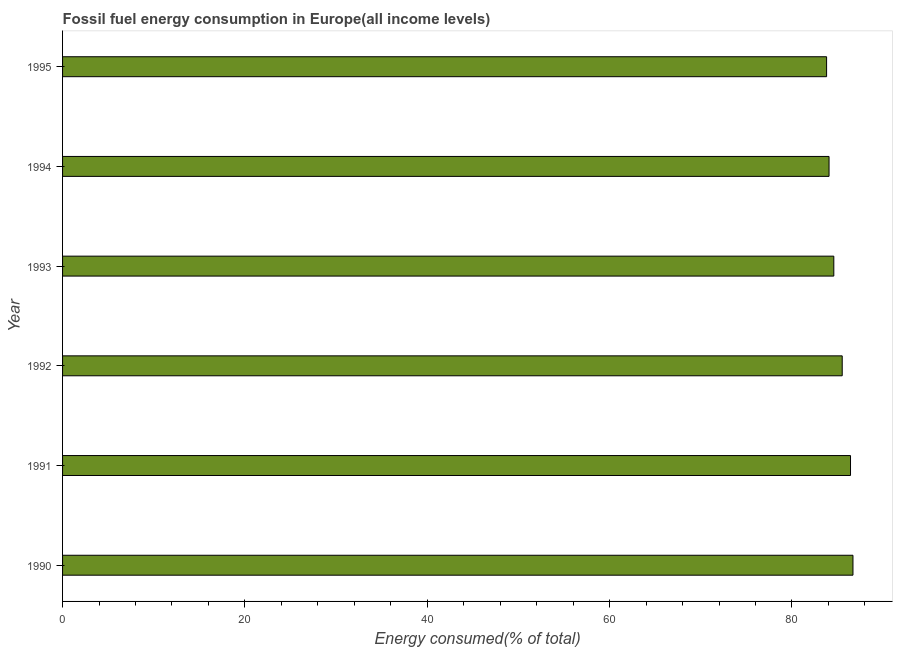Does the graph contain any zero values?
Offer a very short reply. No. What is the title of the graph?
Ensure brevity in your answer.  Fossil fuel energy consumption in Europe(all income levels). What is the label or title of the X-axis?
Offer a very short reply. Energy consumed(% of total). What is the fossil fuel energy consumption in 1995?
Give a very brief answer. 83.8. Across all years, what is the maximum fossil fuel energy consumption?
Your response must be concise. 86.69. Across all years, what is the minimum fossil fuel energy consumption?
Ensure brevity in your answer.  83.8. In which year was the fossil fuel energy consumption minimum?
Keep it short and to the point. 1995. What is the sum of the fossil fuel energy consumption?
Your answer should be very brief. 511.1. What is the difference between the fossil fuel energy consumption in 1990 and 1995?
Ensure brevity in your answer.  2.89. What is the average fossil fuel energy consumption per year?
Ensure brevity in your answer.  85.18. What is the median fossil fuel energy consumption?
Your answer should be compact. 85.05. Do a majority of the years between 1995 and 1994 (inclusive) have fossil fuel energy consumption greater than 20 %?
Offer a very short reply. No. What is the difference between the highest and the second highest fossil fuel energy consumption?
Ensure brevity in your answer.  0.27. Is the sum of the fossil fuel energy consumption in 1991 and 1992 greater than the maximum fossil fuel energy consumption across all years?
Your answer should be compact. Yes. What is the difference between the highest and the lowest fossil fuel energy consumption?
Offer a terse response. 2.89. In how many years, is the fossil fuel energy consumption greater than the average fossil fuel energy consumption taken over all years?
Your answer should be very brief. 3. How many years are there in the graph?
Ensure brevity in your answer.  6. What is the Energy consumed(% of total) in 1990?
Ensure brevity in your answer.  86.69. What is the Energy consumed(% of total) in 1991?
Offer a terse response. 86.43. What is the Energy consumed(% of total) in 1992?
Ensure brevity in your answer.  85.52. What is the Energy consumed(% of total) of 1993?
Ensure brevity in your answer.  84.59. What is the Energy consumed(% of total) of 1994?
Keep it short and to the point. 84.07. What is the Energy consumed(% of total) of 1995?
Your answer should be compact. 83.8. What is the difference between the Energy consumed(% of total) in 1990 and 1991?
Your response must be concise. 0.27. What is the difference between the Energy consumed(% of total) in 1990 and 1992?
Your answer should be compact. 1.18. What is the difference between the Energy consumed(% of total) in 1990 and 1993?
Give a very brief answer. 2.1. What is the difference between the Energy consumed(% of total) in 1990 and 1994?
Ensure brevity in your answer.  2.62. What is the difference between the Energy consumed(% of total) in 1990 and 1995?
Your answer should be compact. 2.89. What is the difference between the Energy consumed(% of total) in 1991 and 1992?
Give a very brief answer. 0.91. What is the difference between the Energy consumed(% of total) in 1991 and 1993?
Offer a very short reply. 1.83. What is the difference between the Energy consumed(% of total) in 1991 and 1994?
Your answer should be compact. 2.35. What is the difference between the Energy consumed(% of total) in 1991 and 1995?
Your answer should be compact. 2.62. What is the difference between the Energy consumed(% of total) in 1992 and 1993?
Offer a very short reply. 0.92. What is the difference between the Energy consumed(% of total) in 1992 and 1994?
Your answer should be compact. 1.44. What is the difference between the Energy consumed(% of total) in 1992 and 1995?
Your answer should be very brief. 1.71. What is the difference between the Energy consumed(% of total) in 1993 and 1994?
Offer a terse response. 0.52. What is the difference between the Energy consumed(% of total) in 1993 and 1995?
Make the answer very short. 0.79. What is the difference between the Energy consumed(% of total) in 1994 and 1995?
Offer a terse response. 0.27. What is the ratio of the Energy consumed(% of total) in 1990 to that in 1991?
Offer a terse response. 1. What is the ratio of the Energy consumed(% of total) in 1990 to that in 1992?
Provide a short and direct response. 1.01. What is the ratio of the Energy consumed(% of total) in 1990 to that in 1994?
Offer a very short reply. 1.03. What is the ratio of the Energy consumed(% of total) in 1990 to that in 1995?
Give a very brief answer. 1.03. What is the ratio of the Energy consumed(% of total) in 1991 to that in 1994?
Offer a terse response. 1.03. What is the ratio of the Energy consumed(% of total) in 1991 to that in 1995?
Your answer should be very brief. 1.03. 